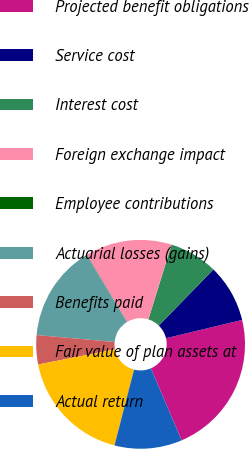<chart> <loc_0><loc_0><loc_500><loc_500><pie_chart><fcel>Projected benefit obligations<fcel>Service cost<fcel>Interest cost<fcel>Foreign exchange impact<fcel>Employee contributions<fcel>Actuarial losses (gains)<fcel>Benefits paid<fcel>Fair value of plan assets at<fcel>Actual return<nl><fcel>22.33%<fcel>8.97%<fcel>7.48%<fcel>13.42%<fcel>0.06%<fcel>14.91%<fcel>4.51%<fcel>17.88%<fcel>10.45%<nl></chart> 